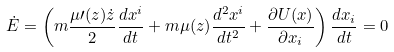<formula> <loc_0><loc_0><loc_500><loc_500>\dot { E } = \left ( m \frac { \mu \prime ( z ) \dot { z } } { 2 } \frac { d x ^ { i } } { d t } + m \mu ( z ) \frac { d ^ { 2 } x ^ { i } } { d t ^ { 2 } } + \frac { \partial U ( x ) } { \partial x _ { i } } \right ) \frac { d x _ { i } } { d t } = 0</formula> 